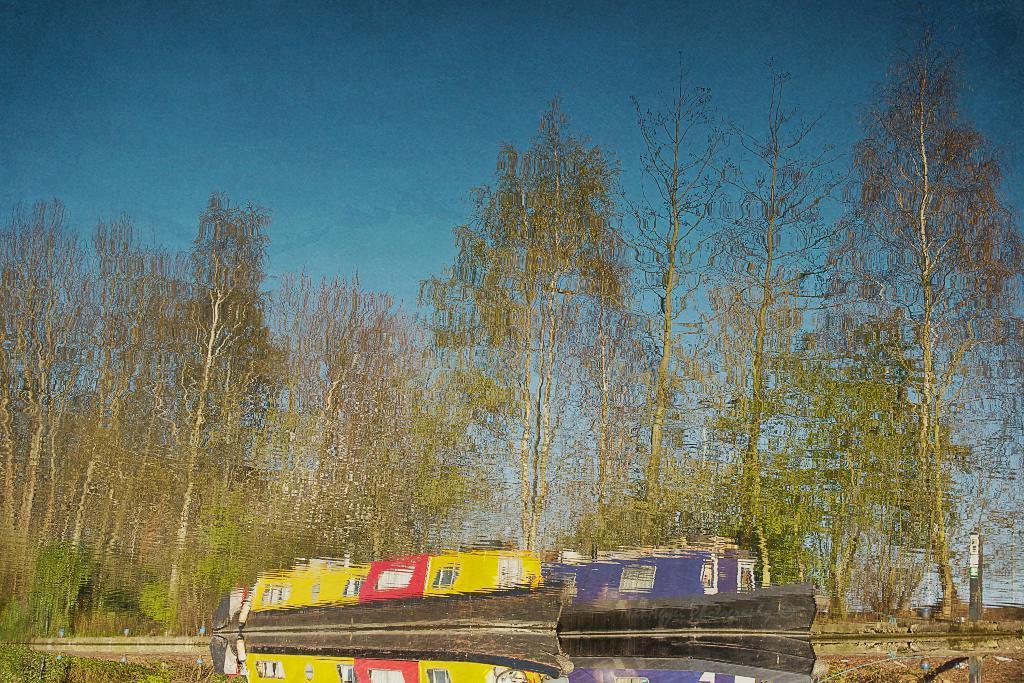In one or two sentences, can you explain what this image depicts? This picture is clicked outside the city. In the center we can see the two boats in the water body. In the background we can see the trees, plants and the sky and some other objects. 